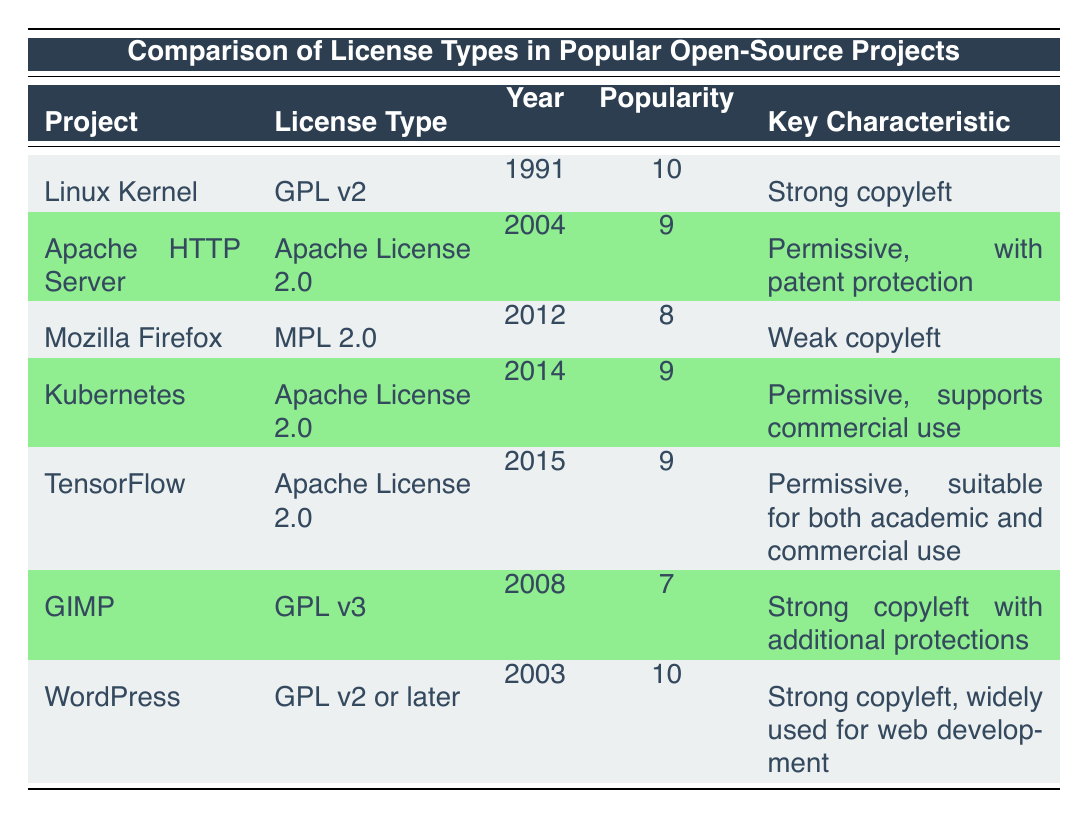What license does the Linux Kernel use? According to the table, the Linux Kernel uses the GPL v2 license type.
Answer: GPL v2 Which project has a popularity score of 10? The table lists both the Linux Kernel and WordPress with a popularity score of 10.
Answer: Linux Kernel, WordPress What year was the Apache License 2.0 introduced? The table shows that the Apache License 2.0 was introduced in the year 2004.
Answer: 2004 What is the key characteristic of the GIMP license? From the table, the GIMP license (GPL v3) has the key characteristic of being strong copyleft with additional protections.
Answer: Strong copyleft with additional protections How many projects use a license type with strong copyleft? The table indicates that there are three projects using strong copyleft licenses: Linux Kernel (GPL v2), GIMP (GPL v3), and WordPress (GPL v2 or later).
Answer: 3 What is the median popularity score of the projects listed? To find the median, we first arrange the popularity scores: 7, 8, 9, 9, 9, 10, 10. Since there are 7 scores, the median (middle value) is the 4th score: 9.
Answer: 9 Is the Mozilla Firefox license a strong copyleft? In the table, the license type for Mozilla Firefox is MPL 2.0, which is classified as weak copyleft, so it is not a strong copyleft.
Answer: No Which license type was introduced most recently? Analyzing the years, the Apache License 2.0 was introduced in 2004, MPL 2.0 in 2012, and the other licenses were introduced earlier. The most recent is therefore the MPL 2.0 from 2012.
Answer: MPL 2.0 How many projects use the Apache License 2.0? The table lists three projects using the Apache License 2.0: Apache HTTP Server, Kubernetes, and TensorFlow.
Answer: 3 